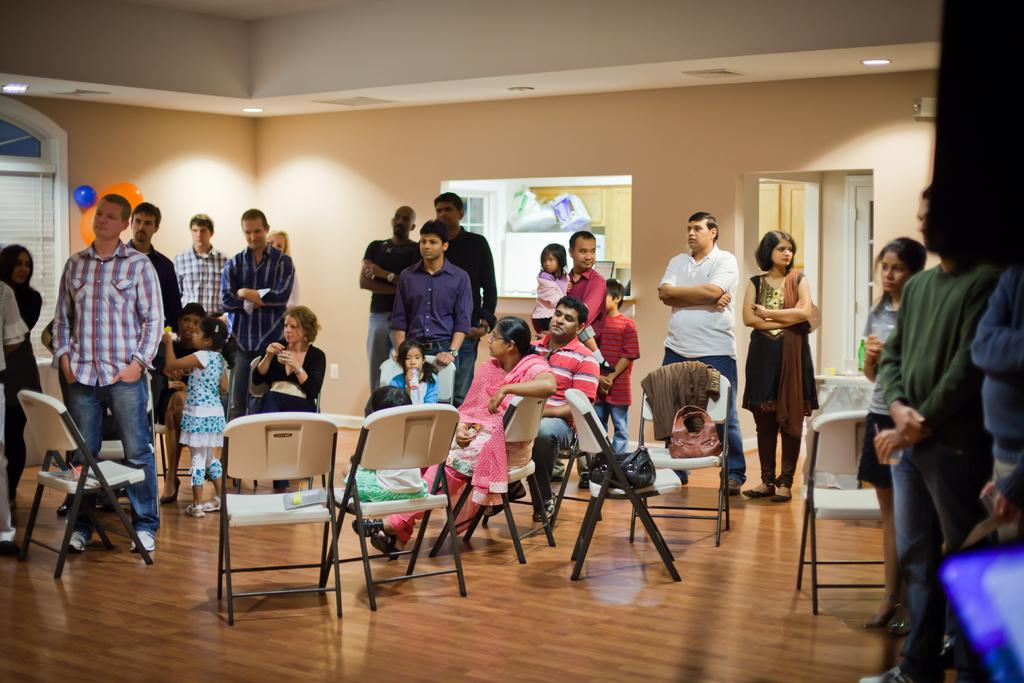How many people are in the image? There is a group of people in the image, but the exact number is not specified. What are the people in the image doing? Some people are standing, while others are sitting. What type of furniture is present in the image? There are chairs in the image. What is the floor made of? The floor is made of wood. What is the source of light in the image? There are lights fixed to the ceiling. Can you see a cook preparing a meal in the image? There is no cook or meal preparation visible in the image. What type of sofa is present in the image? There is no sofa present in the image. 